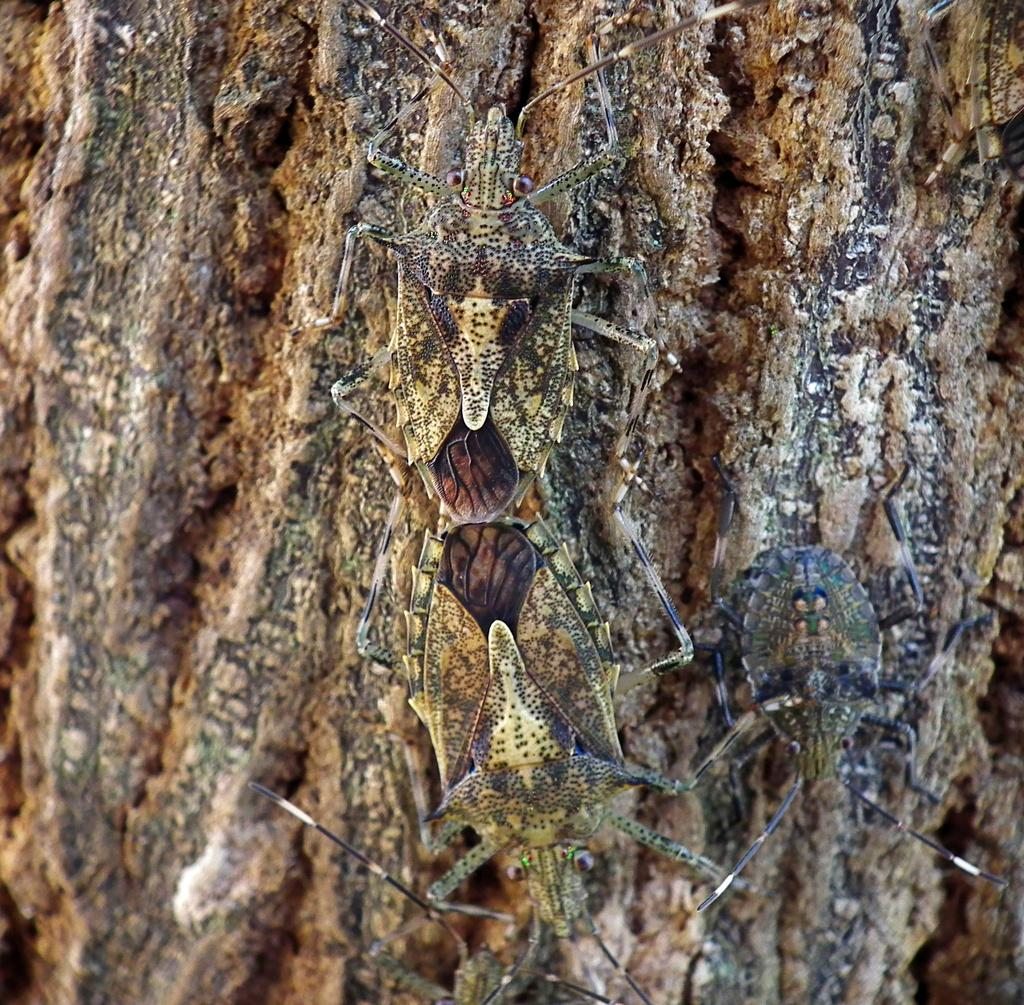What type of living organisms can be seen on the tree trunk in the image? There are insects on the tree trunk in the image. What type of shirt is the insect wearing in the image? There are no insects wearing shirts in the image, as insects do not wear clothing. 